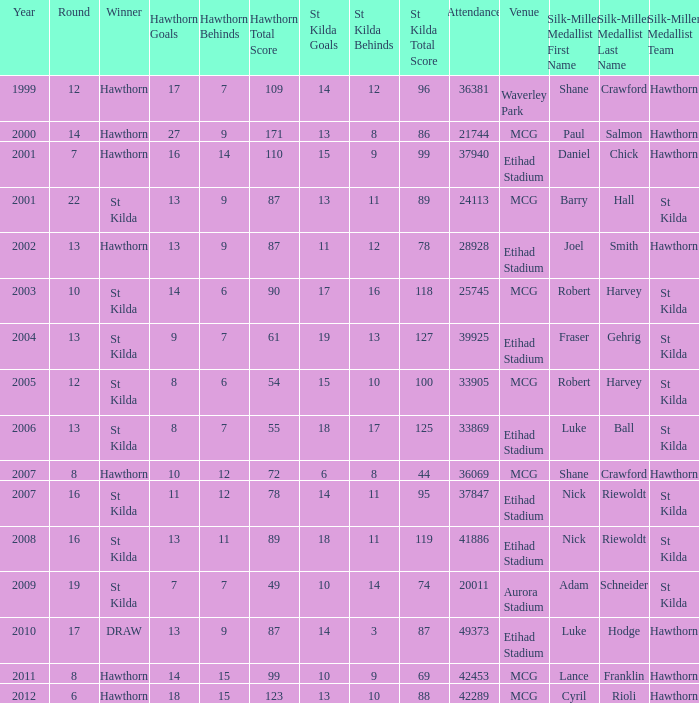Can you parse all the data within this table? {'header': ['Year', 'Round', 'Winner', 'Hawthorn Goals', 'Hawthorn Behinds', 'Hawthorn Total Score', 'St Kilda Goals', 'St Kilda Behinds', 'St Kilda Total Score', 'Attendance', 'Venue', 'Silk-Miller Medallist First Name', 'Silk-Miller Medallist Last Name', 'Silk-Miller Medallist Team'], 'rows': [['1999', '12', 'Hawthorn', '17', '7', '109', '14', '12', '96', '36381', 'Waverley Park', 'Shane', 'Crawford', 'Hawthorn'], ['2000', '14', 'Hawthorn', '27', '9', '171', '13', '8', '86', '21744', 'MCG', 'Paul', 'Salmon', 'Hawthorn'], ['2001', '7', 'Hawthorn', '16', '14', '110', '15', '9', '99', '37940', 'Etihad Stadium', 'Daniel', 'Chick', 'Hawthorn'], ['2001', '22', 'St Kilda', '13', '9', '87', '13', '11', '89', '24113', 'MCG', 'Barry', 'Hall', 'St Kilda'], ['2002', '13', 'Hawthorn', '13', '9', '87', '11', '12', '78', '28928', 'Etihad Stadium', 'Joel', 'Smith', 'Hawthorn'], ['2003', '10', 'St Kilda', '14', '6', '90', '17', '16', '118', '25745', 'MCG', 'Robert', 'Harvey', 'St Kilda'], ['2004', '13', 'St Kilda', '9', '7', '61', '19', '13', '127', '39925', 'Etihad Stadium', 'Fraser', 'Gehrig', 'St Kilda'], ['2005', '12', 'St Kilda', '8', '6', '54', '15', '10', '100', '33905', 'MCG', 'Robert', 'Harvey', 'St Kilda'], ['2006', '13', 'St Kilda', '8', '7', '55', '18', '17', '125', '33869', 'Etihad Stadium', 'Luke', 'Ball', 'St Kilda'], ['2007', '8', 'Hawthorn', '10', '12', '72', '6', '8', '44', '36069', 'MCG', 'Shane', 'Crawford', 'Hawthorn'], ['2007', '16', 'St Kilda', '11', '12', '78', '14', '11', '95', '37847', 'Etihad Stadium', 'Nick', 'Riewoldt', 'St Kilda'], ['2008', '16', 'St Kilda', '13', '11', '89', '18', '11', '119', '41886', 'Etihad Stadium', 'Nick', 'Riewoldt', 'St Kilda'], ['2009', '19', 'St Kilda', '7', '7', '49', '10', '14', '74', '20011', 'Aurora Stadium', 'Adam', 'Schneider', 'St Kilda'], ['2010', '17', 'DRAW', '13', '9', '87', '14', '3', '87', '49373', 'Etihad Stadium', 'Luke', 'Hodge', 'Hawthorn'], ['2011', '8', 'Hawthorn', '14', '15', '99', '10', '9', '69', '42453', 'MCG', 'Lance', 'Franklin', 'Hawthorn'], ['2012', '6', 'Hawthorn', '18', '15', '123', '13', '10', '88', '42289', 'MCG', 'Cyril', 'Rioli', 'Hawthorn']]} What is the attendance when the st kilda score is 13.10.88? 42289.0. 